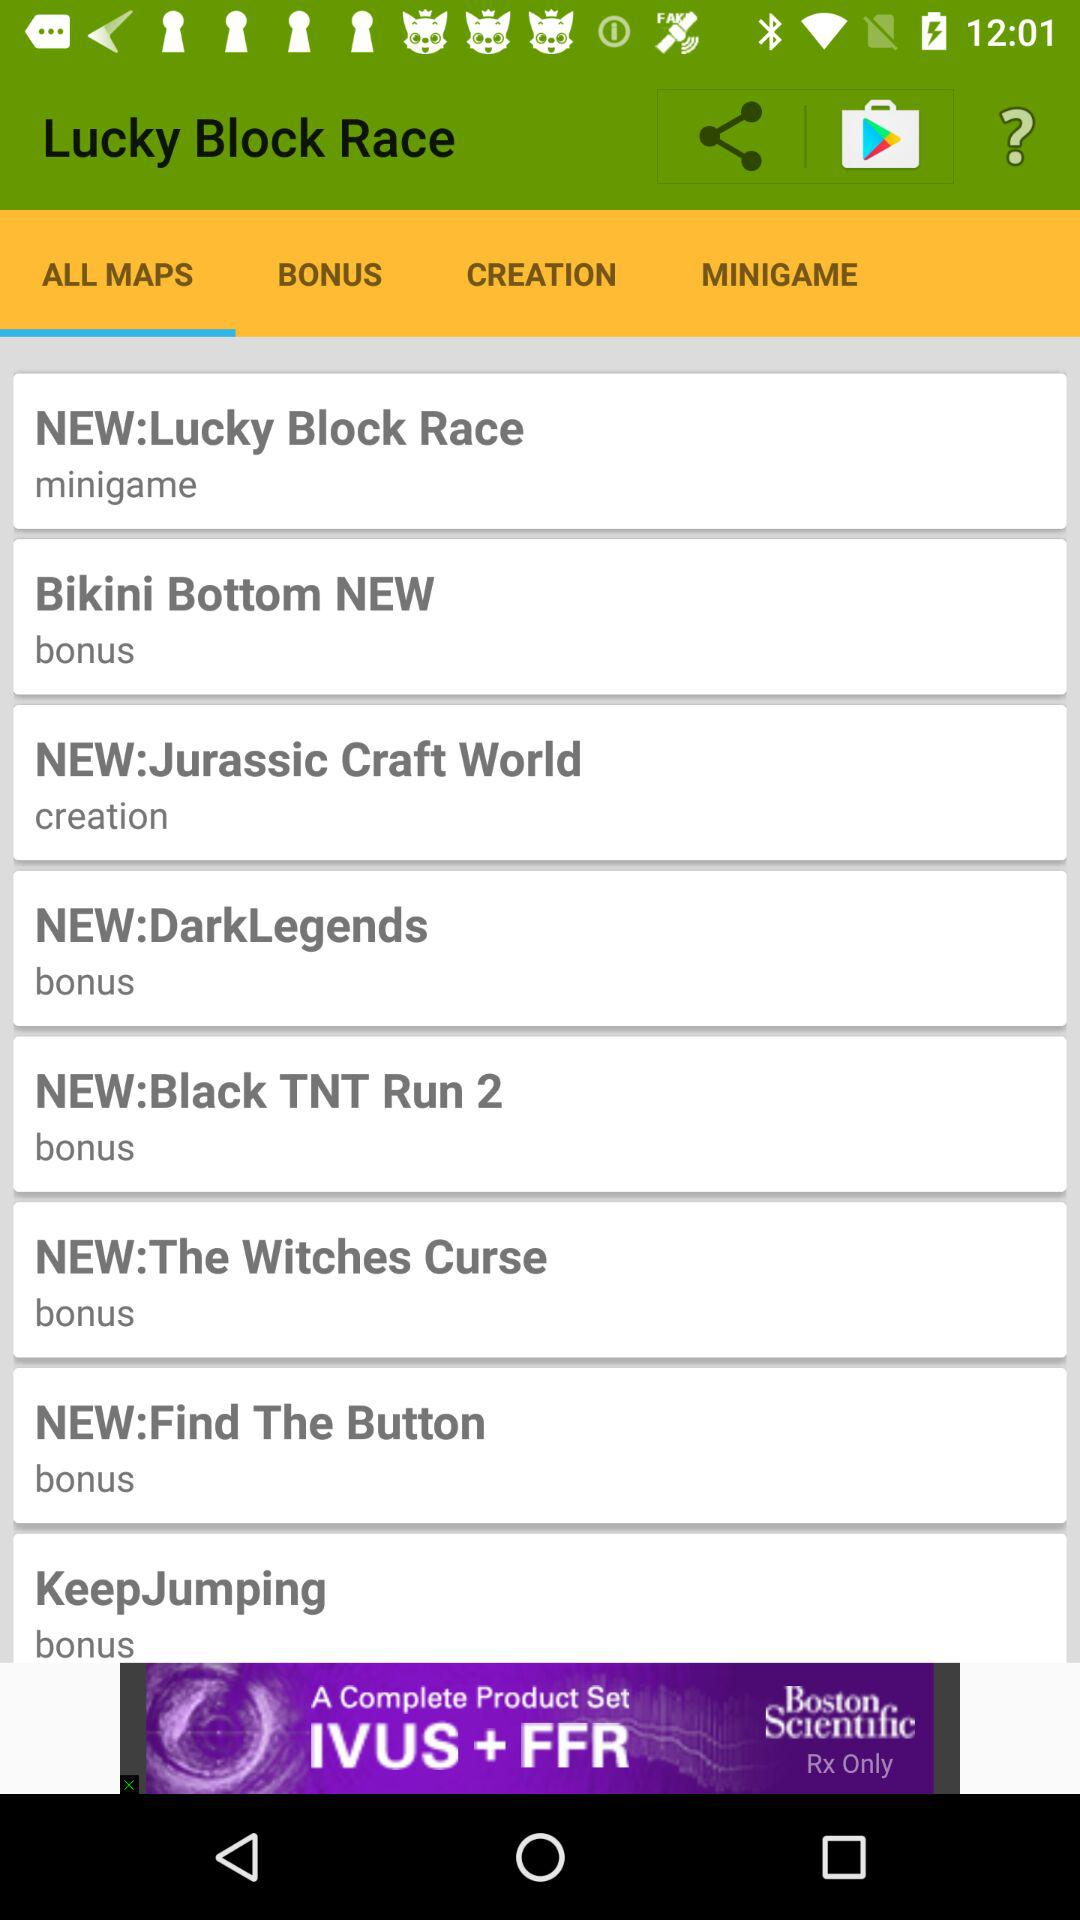How many bonus maps are there?
Answer the question using a single word or phrase. 6 